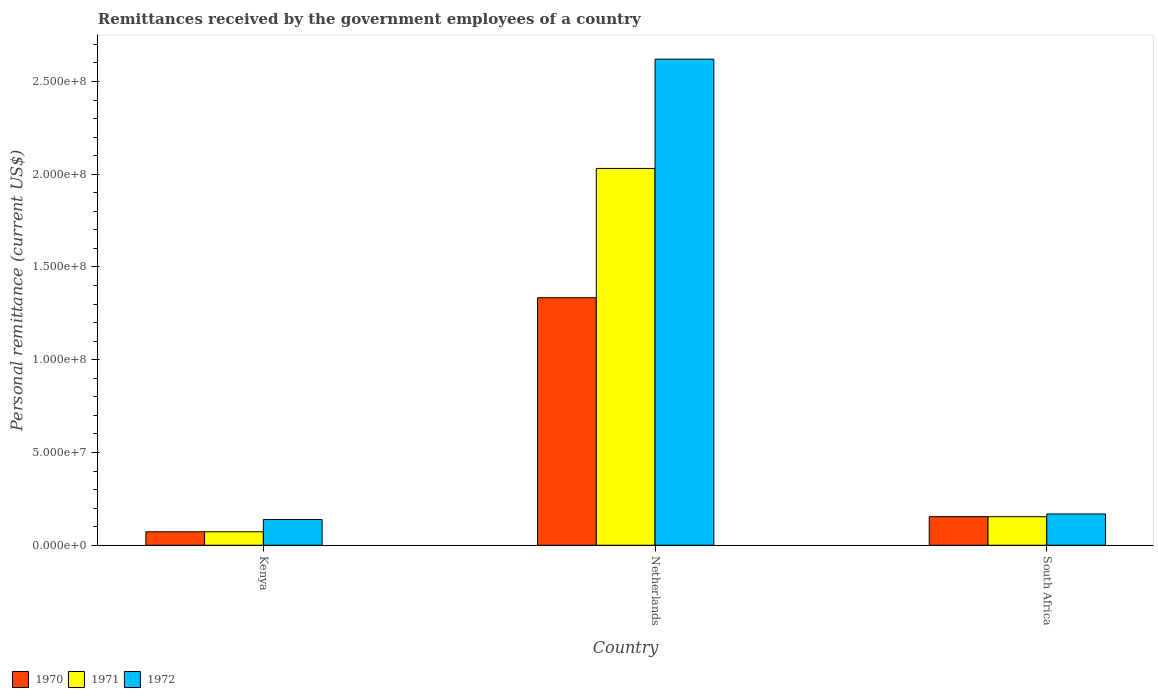Are the number of bars per tick equal to the number of legend labels?
Give a very brief answer. Yes. Are the number of bars on each tick of the X-axis equal?
Make the answer very short. Yes. How many bars are there on the 3rd tick from the left?
Make the answer very short. 3. How many bars are there on the 2nd tick from the right?
Your response must be concise. 3. What is the label of the 2nd group of bars from the left?
Offer a very short reply. Netherlands. In how many cases, is the number of bars for a given country not equal to the number of legend labels?
Your answer should be very brief. 0. What is the remittances received by the government employees in 1970 in Kenya?
Keep it short and to the point. 7.26e+06. Across all countries, what is the maximum remittances received by the government employees in 1970?
Provide a short and direct response. 1.33e+08. Across all countries, what is the minimum remittances received by the government employees in 1970?
Provide a short and direct response. 7.26e+06. In which country was the remittances received by the government employees in 1970 maximum?
Offer a terse response. Netherlands. In which country was the remittances received by the government employees in 1971 minimum?
Offer a very short reply. Kenya. What is the total remittances received by the government employees in 1972 in the graph?
Make the answer very short. 2.93e+08. What is the difference between the remittances received by the government employees in 1971 in Kenya and that in Netherlands?
Make the answer very short. -1.96e+08. What is the difference between the remittances received by the government employees in 1971 in South Africa and the remittances received by the government employees in 1972 in Netherlands?
Your answer should be very brief. -2.47e+08. What is the average remittances received by the government employees in 1972 per country?
Offer a very short reply. 9.76e+07. What is the difference between the remittances received by the government employees of/in 1970 and remittances received by the government employees of/in 1972 in South Africa?
Make the answer very short. -1.47e+06. What is the ratio of the remittances received by the government employees in 1972 in Netherlands to that in South Africa?
Offer a very short reply. 15.53. Is the remittances received by the government employees in 1970 in Netherlands less than that in South Africa?
Your response must be concise. No. What is the difference between the highest and the second highest remittances received by the government employees in 1972?
Offer a terse response. 2.45e+08. What is the difference between the highest and the lowest remittances received by the government employees in 1971?
Make the answer very short. 1.96e+08. Is the sum of the remittances received by the government employees in 1971 in Kenya and Netherlands greater than the maximum remittances received by the government employees in 1970 across all countries?
Your response must be concise. Yes. What does the 3rd bar from the right in Kenya represents?
Your answer should be compact. 1970. Are all the bars in the graph horizontal?
Keep it short and to the point. No. How many countries are there in the graph?
Keep it short and to the point. 3. Are the values on the major ticks of Y-axis written in scientific E-notation?
Make the answer very short. Yes. Does the graph contain any zero values?
Your answer should be compact. No. Does the graph contain grids?
Your answer should be very brief. No. How many legend labels are there?
Offer a very short reply. 3. How are the legend labels stacked?
Provide a short and direct response. Horizontal. What is the title of the graph?
Offer a terse response. Remittances received by the government employees of a country. Does "1971" appear as one of the legend labels in the graph?
Provide a short and direct response. Yes. What is the label or title of the X-axis?
Keep it short and to the point. Country. What is the label or title of the Y-axis?
Your answer should be compact. Personal remittance (current US$). What is the Personal remittance (current US$) of 1970 in Kenya?
Provide a succinct answer. 7.26e+06. What is the Personal remittance (current US$) in 1971 in Kenya?
Make the answer very short. 7.26e+06. What is the Personal remittance (current US$) in 1972 in Kenya?
Your answer should be very brief. 1.39e+07. What is the Personal remittance (current US$) in 1970 in Netherlands?
Ensure brevity in your answer.  1.33e+08. What is the Personal remittance (current US$) in 1971 in Netherlands?
Keep it short and to the point. 2.03e+08. What is the Personal remittance (current US$) of 1972 in Netherlands?
Your answer should be very brief. 2.62e+08. What is the Personal remittance (current US$) in 1970 in South Africa?
Make the answer very short. 1.54e+07. What is the Personal remittance (current US$) of 1971 in South Africa?
Your answer should be very brief. 1.54e+07. What is the Personal remittance (current US$) of 1972 in South Africa?
Provide a short and direct response. 1.69e+07. Across all countries, what is the maximum Personal remittance (current US$) in 1970?
Your answer should be very brief. 1.33e+08. Across all countries, what is the maximum Personal remittance (current US$) of 1971?
Give a very brief answer. 2.03e+08. Across all countries, what is the maximum Personal remittance (current US$) of 1972?
Your answer should be compact. 2.62e+08. Across all countries, what is the minimum Personal remittance (current US$) of 1970?
Provide a succinct answer. 7.26e+06. Across all countries, what is the minimum Personal remittance (current US$) of 1971?
Offer a very short reply. 7.26e+06. Across all countries, what is the minimum Personal remittance (current US$) in 1972?
Offer a terse response. 1.39e+07. What is the total Personal remittance (current US$) of 1970 in the graph?
Make the answer very short. 1.56e+08. What is the total Personal remittance (current US$) of 1971 in the graph?
Provide a succinct answer. 2.26e+08. What is the total Personal remittance (current US$) of 1972 in the graph?
Provide a succinct answer. 2.93e+08. What is the difference between the Personal remittance (current US$) of 1970 in Kenya and that in Netherlands?
Keep it short and to the point. -1.26e+08. What is the difference between the Personal remittance (current US$) of 1971 in Kenya and that in Netherlands?
Your answer should be very brief. -1.96e+08. What is the difference between the Personal remittance (current US$) of 1972 in Kenya and that in Netherlands?
Give a very brief answer. -2.48e+08. What is the difference between the Personal remittance (current US$) of 1970 in Kenya and that in South Africa?
Offer a very short reply. -8.14e+06. What is the difference between the Personal remittance (current US$) of 1971 in Kenya and that in South Africa?
Provide a short and direct response. -8.12e+06. What is the difference between the Personal remittance (current US$) of 1972 in Kenya and that in South Africa?
Make the answer very short. -3.01e+06. What is the difference between the Personal remittance (current US$) in 1970 in Netherlands and that in South Africa?
Your answer should be compact. 1.18e+08. What is the difference between the Personal remittance (current US$) in 1971 in Netherlands and that in South Africa?
Your response must be concise. 1.88e+08. What is the difference between the Personal remittance (current US$) of 1972 in Netherlands and that in South Africa?
Offer a very short reply. 2.45e+08. What is the difference between the Personal remittance (current US$) of 1970 in Kenya and the Personal remittance (current US$) of 1971 in Netherlands?
Give a very brief answer. -1.96e+08. What is the difference between the Personal remittance (current US$) of 1970 in Kenya and the Personal remittance (current US$) of 1972 in Netherlands?
Offer a very short reply. -2.55e+08. What is the difference between the Personal remittance (current US$) in 1971 in Kenya and the Personal remittance (current US$) in 1972 in Netherlands?
Keep it short and to the point. -2.55e+08. What is the difference between the Personal remittance (current US$) in 1970 in Kenya and the Personal remittance (current US$) in 1971 in South Africa?
Make the answer very short. -8.12e+06. What is the difference between the Personal remittance (current US$) of 1970 in Kenya and the Personal remittance (current US$) of 1972 in South Africa?
Provide a succinct answer. -9.61e+06. What is the difference between the Personal remittance (current US$) in 1971 in Kenya and the Personal remittance (current US$) in 1972 in South Africa?
Give a very brief answer. -9.61e+06. What is the difference between the Personal remittance (current US$) of 1970 in Netherlands and the Personal remittance (current US$) of 1971 in South Africa?
Your answer should be very brief. 1.18e+08. What is the difference between the Personal remittance (current US$) in 1970 in Netherlands and the Personal remittance (current US$) in 1972 in South Africa?
Provide a short and direct response. 1.17e+08. What is the difference between the Personal remittance (current US$) in 1971 in Netherlands and the Personal remittance (current US$) in 1972 in South Africa?
Provide a succinct answer. 1.86e+08. What is the average Personal remittance (current US$) of 1970 per country?
Your answer should be compact. 5.20e+07. What is the average Personal remittance (current US$) in 1971 per country?
Provide a succinct answer. 7.53e+07. What is the average Personal remittance (current US$) of 1972 per country?
Your answer should be compact. 9.76e+07. What is the difference between the Personal remittance (current US$) in 1970 and Personal remittance (current US$) in 1972 in Kenya?
Your answer should be very brief. -6.60e+06. What is the difference between the Personal remittance (current US$) in 1971 and Personal remittance (current US$) in 1972 in Kenya?
Your answer should be compact. -6.60e+06. What is the difference between the Personal remittance (current US$) of 1970 and Personal remittance (current US$) of 1971 in Netherlands?
Offer a very short reply. -6.97e+07. What is the difference between the Personal remittance (current US$) of 1970 and Personal remittance (current US$) of 1972 in Netherlands?
Provide a succinct answer. -1.29e+08. What is the difference between the Personal remittance (current US$) of 1971 and Personal remittance (current US$) of 1972 in Netherlands?
Give a very brief answer. -5.89e+07. What is the difference between the Personal remittance (current US$) in 1970 and Personal remittance (current US$) in 1971 in South Africa?
Offer a very short reply. 2.18e+04. What is the difference between the Personal remittance (current US$) of 1970 and Personal remittance (current US$) of 1972 in South Africa?
Offer a terse response. -1.47e+06. What is the difference between the Personal remittance (current US$) of 1971 and Personal remittance (current US$) of 1972 in South Africa?
Your response must be concise. -1.49e+06. What is the ratio of the Personal remittance (current US$) of 1970 in Kenya to that in Netherlands?
Your answer should be compact. 0.05. What is the ratio of the Personal remittance (current US$) of 1971 in Kenya to that in Netherlands?
Your answer should be very brief. 0.04. What is the ratio of the Personal remittance (current US$) in 1972 in Kenya to that in Netherlands?
Provide a short and direct response. 0.05. What is the ratio of the Personal remittance (current US$) in 1970 in Kenya to that in South Africa?
Offer a very short reply. 0.47. What is the ratio of the Personal remittance (current US$) of 1971 in Kenya to that in South Africa?
Offer a terse response. 0.47. What is the ratio of the Personal remittance (current US$) of 1972 in Kenya to that in South Africa?
Give a very brief answer. 0.82. What is the ratio of the Personal remittance (current US$) of 1970 in Netherlands to that in South Africa?
Your response must be concise. 8.66. What is the ratio of the Personal remittance (current US$) of 1971 in Netherlands to that in South Africa?
Ensure brevity in your answer.  13.21. What is the ratio of the Personal remittance (current US$) in 1972 in Netherlands to that in South Africa?
Provide a succinct answer. 15.53. What is the difference between the highest and the second highest Personal remittance (current US$) in 1970?
Provide a succinct answer. 1.18e+08. What is the difference between the highest and the second highest Personal remittance (current US$) of 1971?
Give a very brief answer. 1.88e+08. What is the difference between the highest and the second highest Personal remittance (current US$) in 1972?
Give a very brief answer. 2.45e+08. What is the difference between the highest and the lowest Personal remittance (current US$) in 1970?
Ensure brevity in your answer.  1.26e+08. What is the difference between the highest and the lowest Personal remittance (current US$) in 1971?
Offer a very short reply. 1.96e+08. What is the difference between the highest and the lowest Personal remittance (current US$) in 1972?
Your answer should be very brief. 2.48e+08. 